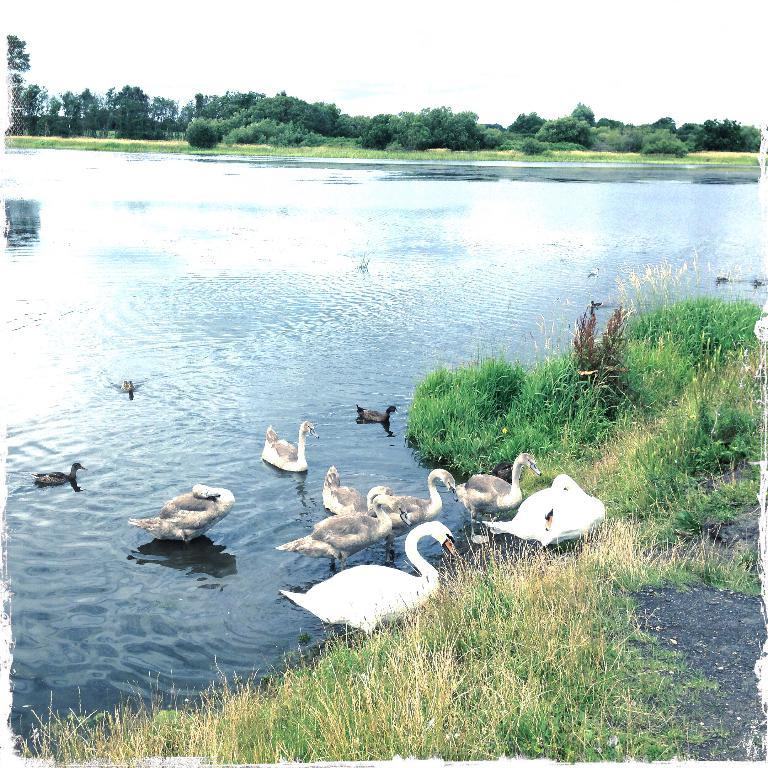What is the main element present in the image? There is water in the image. What type of vegetation can be seen in the image? There is grass in the image. What animals are present in the water? There are ducks in the water. What can be seen in the background of the image? There is a group of trees behind the water. What is visible at the top of the image? The sky is visible at the top of the image. What type of operation is being performed on the ducks in the image? There is no operation being performed on the ducks in the image; they are simply swimming in the water. What arithmetic problem can be solved using the number of trees in the image? There is no arithmetic problem to be solved using the number of trees in the image, as the number of trees is not mentioned in the provided facts. 